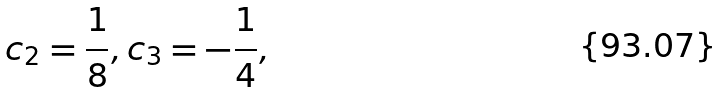Convert formula to latex. <formula><loc_0><loc_0><loc_500><loc_500>& c _ { 2 } = \frac { 1 } { 8 } , c _ { 3 } = - \frac { 1 } { 4 } ,</formula> 